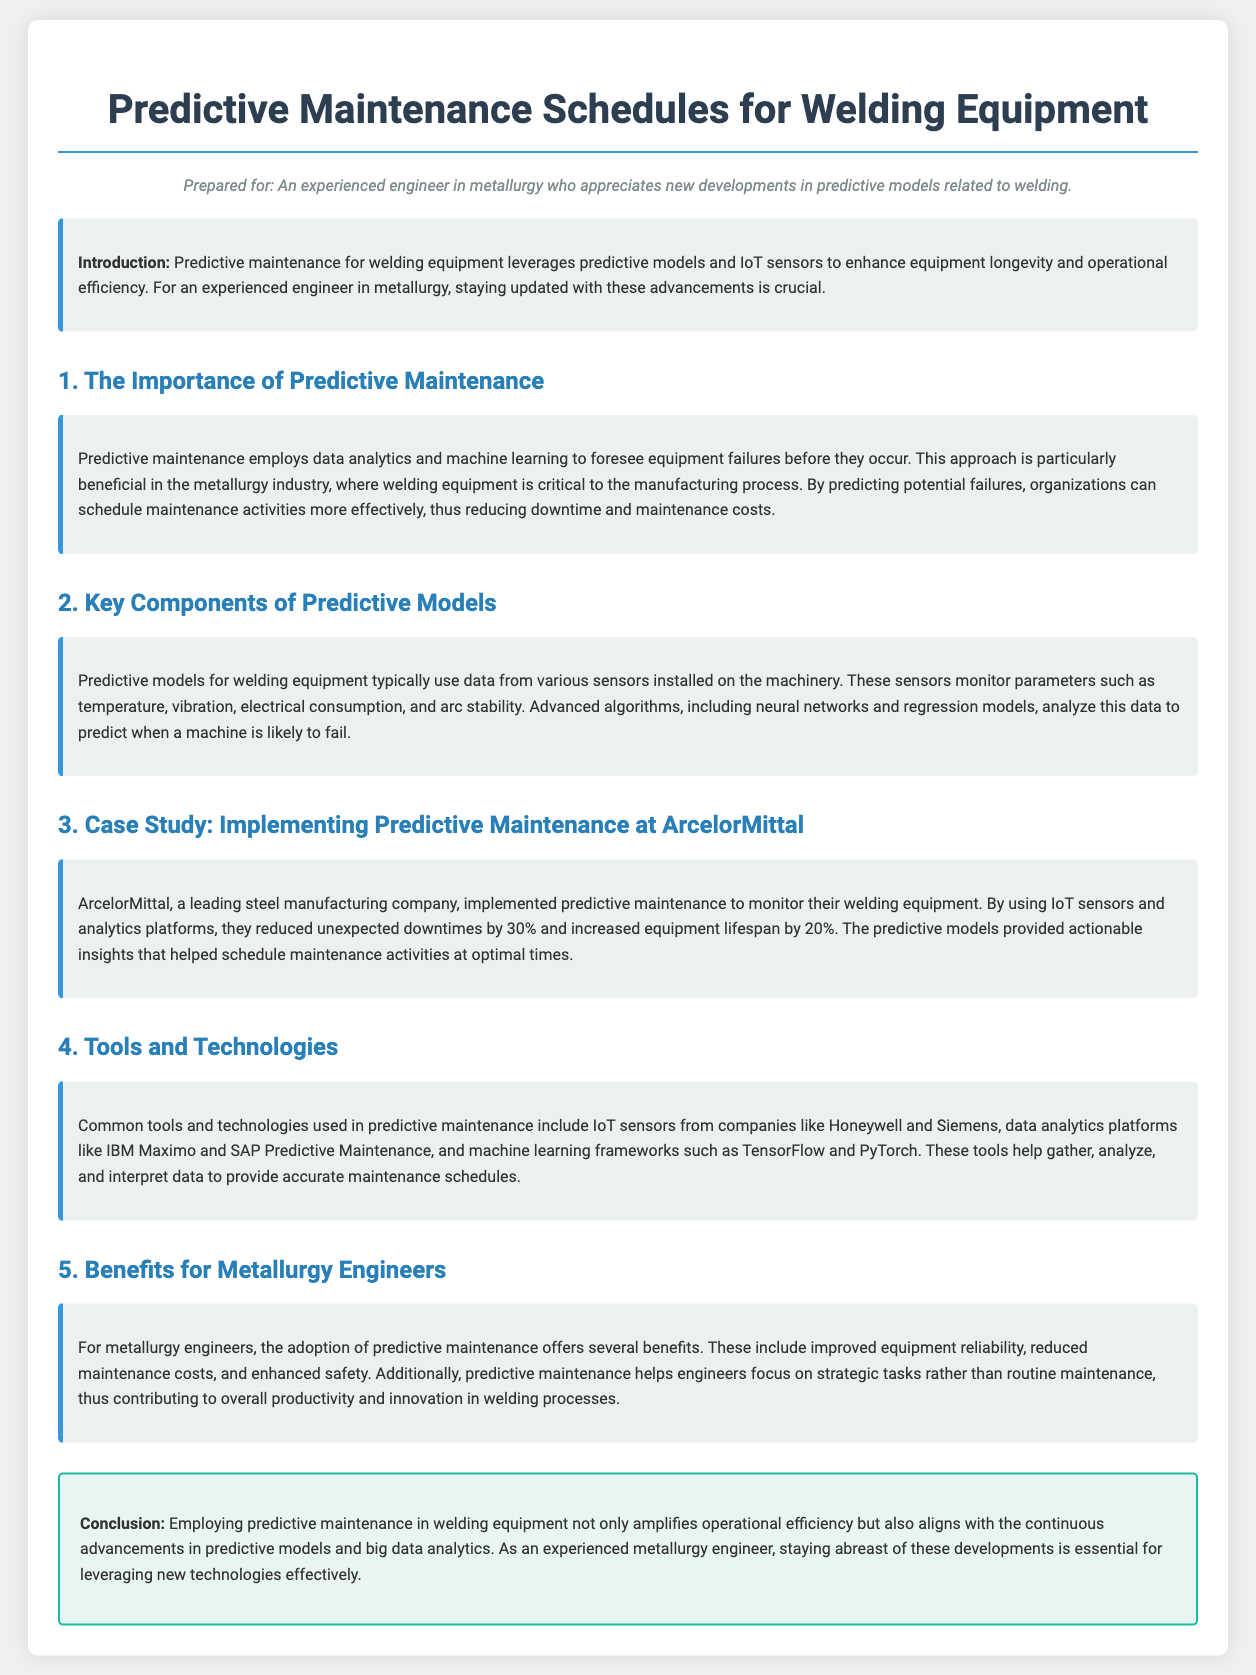What is the primary benefit of predictive maintenance? Predictive maintenance provides the ability to foresee equipment failures before they occur, thus reducing downtime and maintenance costs.
Answer: reducing downtime and maintenance costs What company is mentioned in the case study? The case study referenced in the document is about the implementation of predictive maintenance at a specific steel manufacturing company.
Answer: ArcelorMittal By what percentage did ArcelorMittal reduce unexpected downtimes? This document states specific improvements resulting from the implementation of predictive maintenance, including a numeric reduction in downtime.
Answer: 30% Which tools are commonly used in predictive maintenance? The document lists various tools and technologies relevant to predictive maintenance, pointing to specific examples from manufacturers.
Answer: IoT sensors, data analytics platforms, machine learning frameworks What parameters do the sensors monitor in welding equipment? The text details the types of data collected by sensors for predictive models, highlighting multiple variables monitored during operations.
Answer: temperature, vibration, electrical consumption, arc stability What is the role of advanced algorithms in predictive maintenance? The document explains how algorithms play a crucial role in analyzing sensor data to achieve specific outcomes related to equipment management.
Answer: predict when a machine is likely to fail What is a notable advantage of predictive maintenance for metallurgy engineers? This document emphasizes the outcomes of predictive maintenance from the perspective of engineers in metallurgy, focusing on specific benefits.
Answer: improved equipment reliability What type of analysis is used in predictive maintenance? The document discusses the utilization of several disciplines to enhance maintenance strategies surrounding welding equipment.
Answer: data analytics and machine learning What does the conclusion emphasize about predictive maintenance? The conclusion draws attention to the implications of predictive maintenance in the context of evolving technologies and operational practices.
Answer: amplifies operational efficiency 